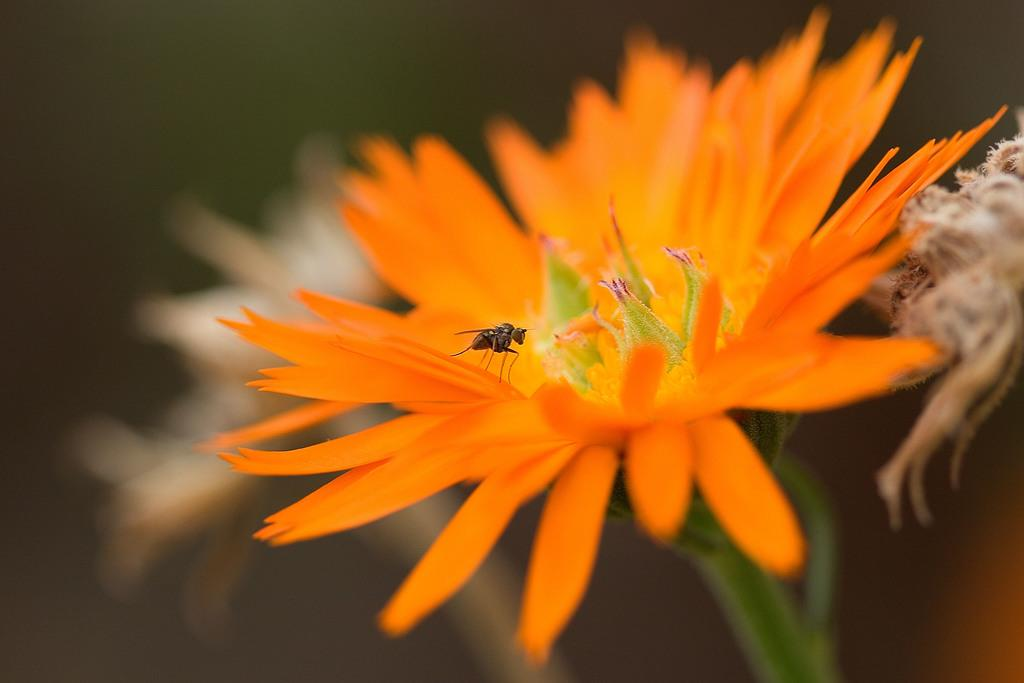What type of flower is present in the image? There is an orange color flower in the image. Are there any other objects or creatures on the flower? A: Yes, there is a fly on the flower. Can you describe the background of the image? The background of the image is blurred. How many tickets are needed to ride the bells in the image? There are no bells or tickets present in the image; it features an orange color flower with a fly on it and a blurred background. 